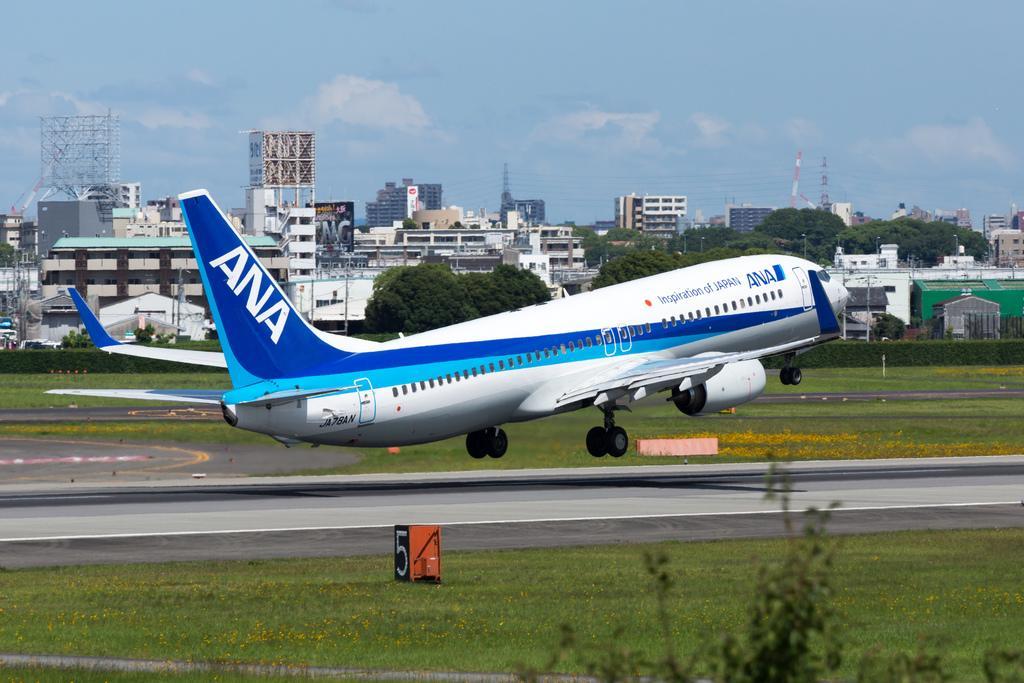Can you describe this image briefly? There is a flight taking off from the runway. On the ground there is grass. Also there is a block with a number. In the background there are buildings and sky. Also there is sky with clouds. 